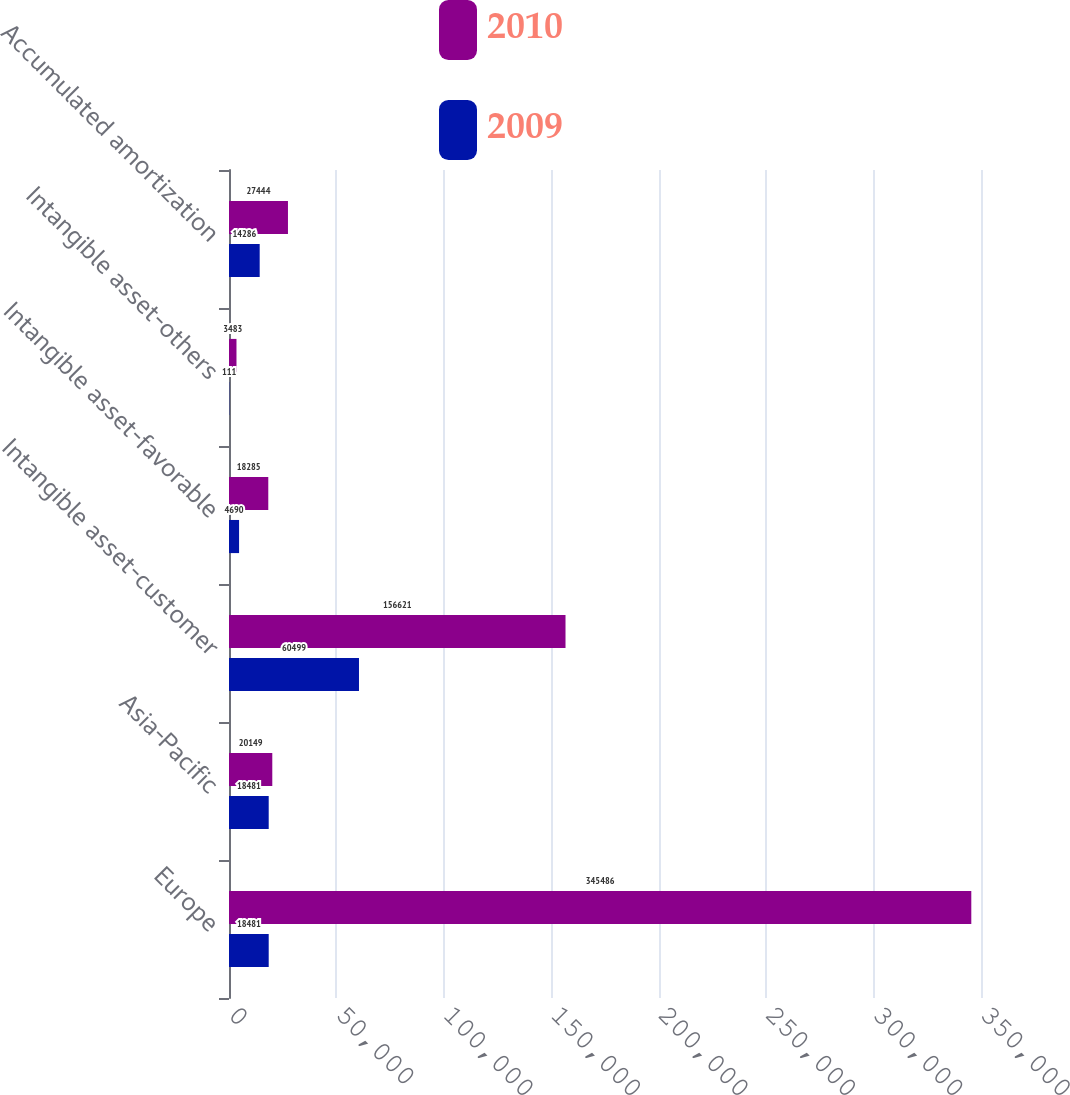<chart> <loc_0><loc_0><loc_500><loc_500><stacked_bar_chart><ecel><fcel>Europe<fcel>Asia-Pacific<fcel>Intangible asset-customer<fcel>Intangible asset-favorable<fcel>Intangible asset-others<fcel>Accumulated amortization<nl><fcel>2010<fcel>345486<fcel>20149<fcel>156621<fcel>18285<fcel>3483<fcel>27444<nl><fcel>2009<fcel>18481<fcel>18481<fcel>60499<fcel>4690<fcel>111<fcel>14286<nl></chart> 